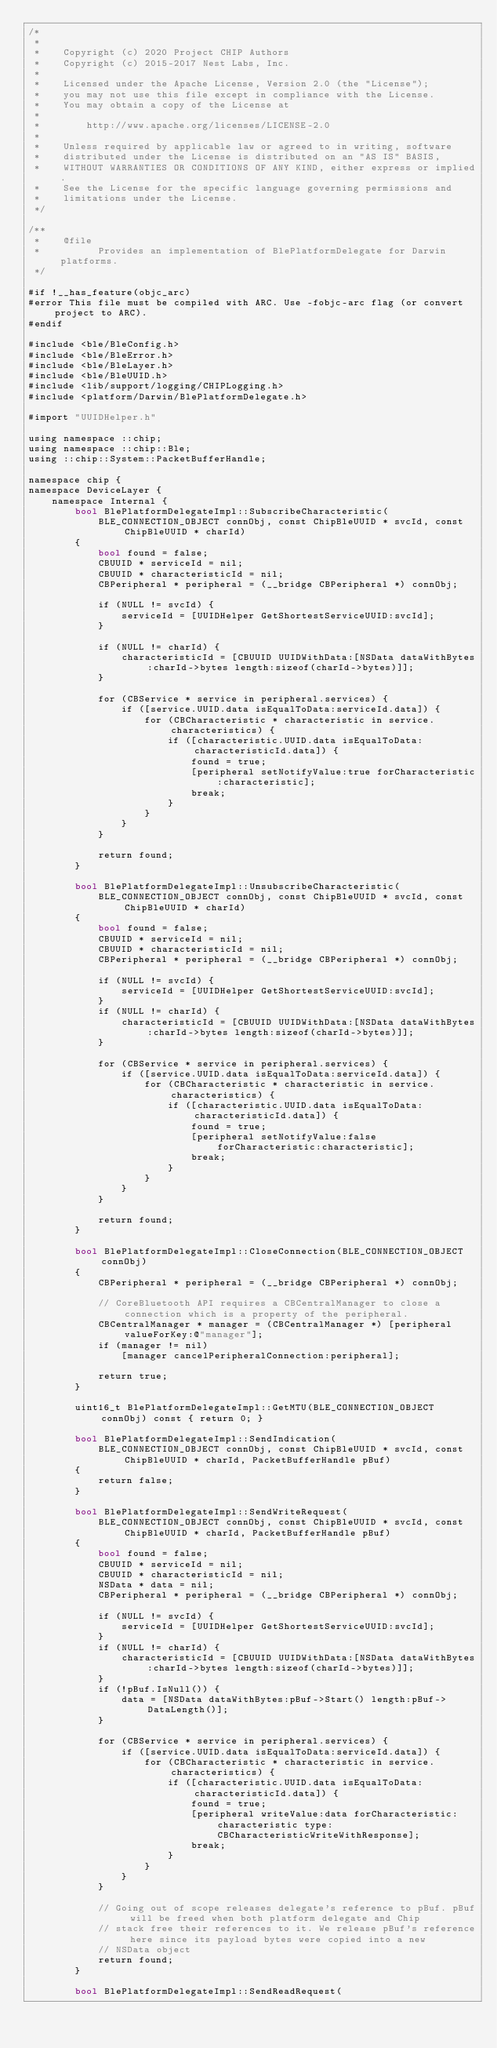<code> <loc_0><loc_0><loc_500><loc_500><_ObjectiveC_>/*
 *
 *    Copyright (c) 2020 Project CHIP Authors
 *    Copyright (c) 2015-2017 Nest Labs, Inc.
 *
 *    Licensed under the Apache License, Version 2.0 (the "License");
 *    you may not use this file except in compliance with the License.
 *    You may obtain a copy of the License at
 *
 *        http://www.apache.org/licenses/LICENSE-2.0
 *
 *    Unless required by applicable law or agreed to in writing, software
 *    distributed under the License is distributed on an "AS IS" BASIS,
 *    WITHOUT WARRANTIES OR CONDITIONS OF ANY KIND, either express or implied.
 *    See the License for the specific language governing permissions and
 *    limitations under the License.
 */

/**
 *    @file
 *          Provides an implementation of BlePlatformDelegate for Darwin platforms.
 */

#if !__has_feature(objc_arc)
#error This file must be compiled with ARC. Use -fobjc-arc flag (or convert project to ARC).
#endif

#include <ble/BleConfig.h>
#include <ble/BleError.h>
#include <ble/BleLayer.h>
#include <ble/BleUUID.h>
#include <lib/support/logging/CHIPLogging.h>
#include <platform/Darwin/BlePlatformDelegate.h>

#import "UUIDHelper.h"

using namespace ::chip;
using namespace ::chip::Ble;
using ::chip::System::PacketBufferHandle;

namespace chip {
namespace DeviceLayer {
    namespace Internal {
        bool BlePlatformDelegateImpl::SubscribeCharacteristic(
            BLE_CONNECTION_OBJECT connObj, const ChipBleUUID * svcId, const ChipBleUUID * charId)
        {
            bool found = false;
            CBUUID * serviceId = nil;
            CBUUID * characteristicId = nil;
            CBPeripheral * peripheral = (__bridge CBPeripheral *) connObj;

            if (NULL != svcId) {
                serviceId = [UUIDHelper GetShortestServiceUUID:svcId];
            }

            if (NULL != charId) {
                characteristicId = [CBUUID UUIDWithData:[NSData dataWithBytes:charId->bytes length:sizeof(charId->bytes)]];
            }

            for (CBService * service in peripheral.services) {
                if ([service.UUID.data isEqualToData:serviceId.data]) {
                    for (CBCharacteristic * characteristic in service.characteristics) {
                        if ([characteristic.UUID.data isEqualToData:characteristicId.data]) {
                            found = true;
                            [peripheral setNotifyValue:true forCharacteristic:characteristic];
                            break;
                        }
                    }
                }
            }

            return found;
        }

        bool BlePlatformDelegateImpl::UnsubscribeCharacteristic(
            BLE_CONNECTION_OBJECT connObj, const ChipBleUUID * svcId, const ChipBleUUID * charId)
        {
            bool found = false;
            CBUUID * serviceId = nil;
            CBUUID * characteristicId = nil;
            CBPeripheral * peripheral = (__bridge CBPeripheral *) connObj;

            if (NULL != svcId) {
                serviceId = [UUIDHelper GetShortestServiceUUID:svcId];
            }
            if (NULL != charId) {
                characteristicId = [CBUUID UUIDWithData:[NSData dataWithBytes:charId->bytes length:sizeof(charId->bytes)]];
            }

            for (CBService * service in peripheral.services) {
                if ([service.UUID.data isEqualToData:serviceId.data]) {
                    for (CBCharacteristic * characteristic in service.characteristics) {
                        if ([characteristic.UUID.data isEqualToData:characteristicId.data]) {
                            found = true;
                            [peripheral setNotifyValue:false forCharacteristic:characteristic];
                            break;
                        }
                    }
                }
            }

            return found;
        }

        bool BlePlatformDelegateImpl::CloseConnection(BLE_CONNECTION_OBJECT connObj)
        {
            CBPeripheral * peripheral = (__bridge CBPeripheral *) connObj;

            // CoreBluetooth API requires a CBCentralManager to close a connection which is a property of the peripheral.
            CBCentralManager * manager = (CBCentralManager *) [peripheral valueForKey:@"manager"];
            if (manager != nil)
                [manager cancelPeripheralConnection:peripheral];

            return true;
        }

        uint16_t BlePlatformDelegateImpl::GetMTU(BLE_CONNECTION_OBJECT connObj) const { return 0; }

        bool BlePlatformDelegateImpl::SendIndication(
            BLE_CONNECTION_OBJECT connObj, const ChipBleUUID * svcId, const ChipBleUUID * charId, PacketBufferHandle pBuf)
        {
            return false;
        }

        bool BlePlatformDelegateImpl::SendWriteRequest(
            BLE_CONNECTION_OBJECT connObj, const ChipBleUUID * svcId, const ChipBleUUID * charId, PacketBufferHandle pBuf)
        {
            bool found = false;
            CBUUID * serviceId = nil;
            CBUUID * characteristicId = nil;
            NSData * data = nil;
            CBPeripheral * peripheral = (__bridge CBPeripheral *) connObj;

            if (NULL != svcId) {
                serviceId = [UUIDHelper GetShortestServiceUUID:svcId];
            }
            if (NULL != charId) {
                characteristicId = [CBUUID UUIDWithData:[NSData dataWithBytes:charId->bytes length:sizeof(charId->bytes)]];
            }
            if (!pBuf.IsNull()) {
                data = [NSData dataWithBytes:pBuf->Start() length:pBuf->DataLength()];
            }

            for (CBService * service in peripheral.services) {
                if ([service.UUID.data isEqualToData:serviceId.data]) {
                    for (CBCharacteristic * characteristic in service.characteristics) {
                        if ([characteristic.UUID.data isEqualToData:characteristicId.data]) {
                            found = true;
                            [peripheral writeValue:data forCharacteristic:characteristic type:CBCharacteristicWriteWithResponse];
                            break;
                        }
                    }
                }
            }

            // Going out of scope releases delegate's reference to pBuf. pBuf will be freed when both platform delegate and Chip
            // stack free their references to it. We release pBuf's reference here since its payload bytes were copied into a new
            // NSData object
            return found;
        }

        bool BlePlatformDelegateImpl::SendReadRequest(</code> 